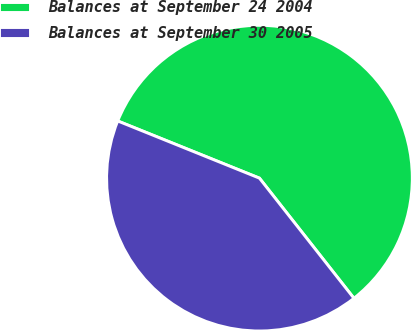<chart> <loc_0><loc_0><loc_500><loc_500><pie_chart><fcel>Balances at September 24 2004<fcel>Balances at September 30 2005<nl><fcel>58.29%<fcel>41.71%<nl></chart> 